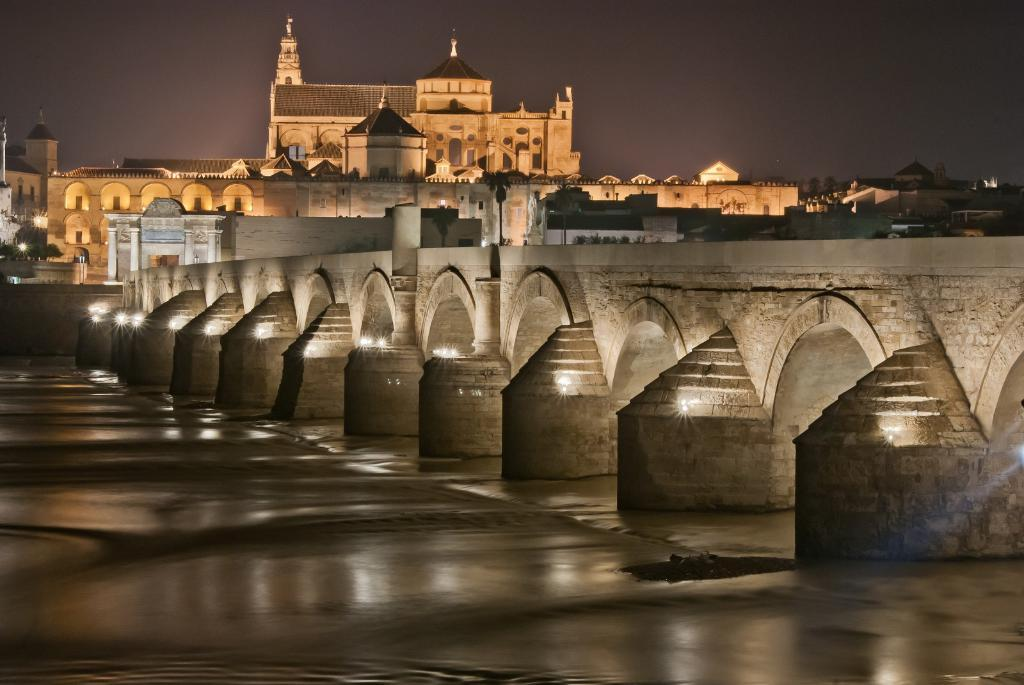What structure is the main subject of the image? There is a bridge in the image. What feature of the bridge is mentioned in the facts? The bridge has lights. What can be seen at the bottom of the image? There is water at the bottom of the image. What is visible in the background of the image? There is a building in the background of the image. What is visible at the top of the image? The sky is visible at the top of the image. Who won the volleyball competition in the image? There is no volleyball competition present in the image; it features a bridge with lights, water, a building, and the sky. 